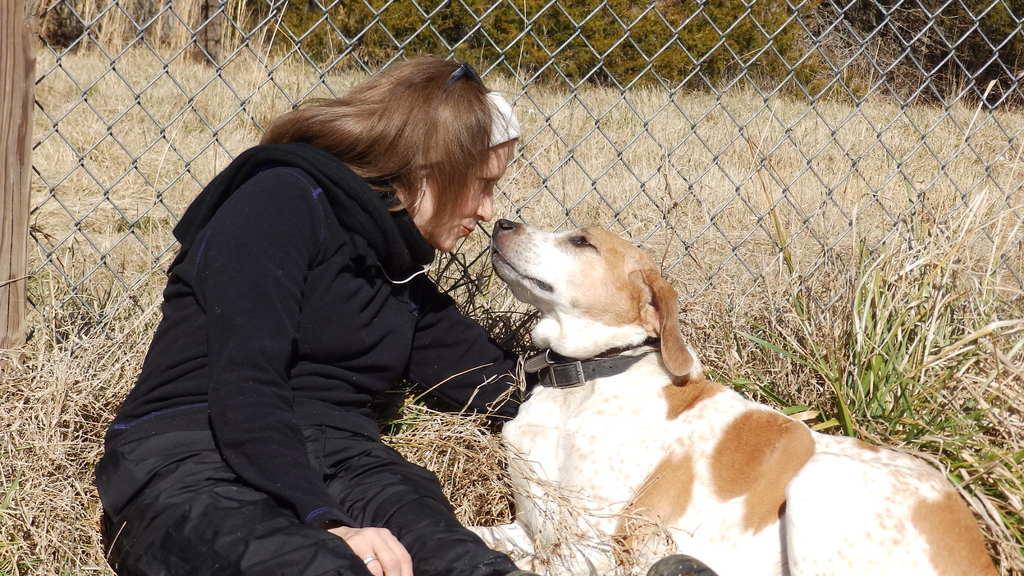In one or two sentences, can you explain what this image depicts? In this image there is a person wearing black color sweater and a dog sitting on the floor and at the background of the image there is a fencing. 